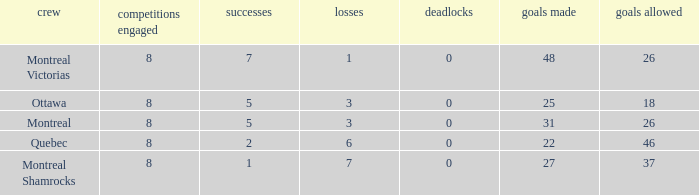Parse the table in full. {'header': ['crew', 'competitions engaged', 'successes', 'losses', 'deadlocks', 'goals made', 'goals allowed'], 'rows': [['Montreal Victorias', '8', '7', '1', '0', '48', '26'], ['Ottawa', '8', '5', '3', '0', '25', '18'], ['Montreal', '8', '5', '3', '0', '31', '26'], ['Quebec', '8', '2', '6', '0', '22', '46'], ['Montreal Shamrocks', '8', '1', '7', '0', '27', '37']]} For teams with 7 wins, what is the number of goals against? 26.0. 